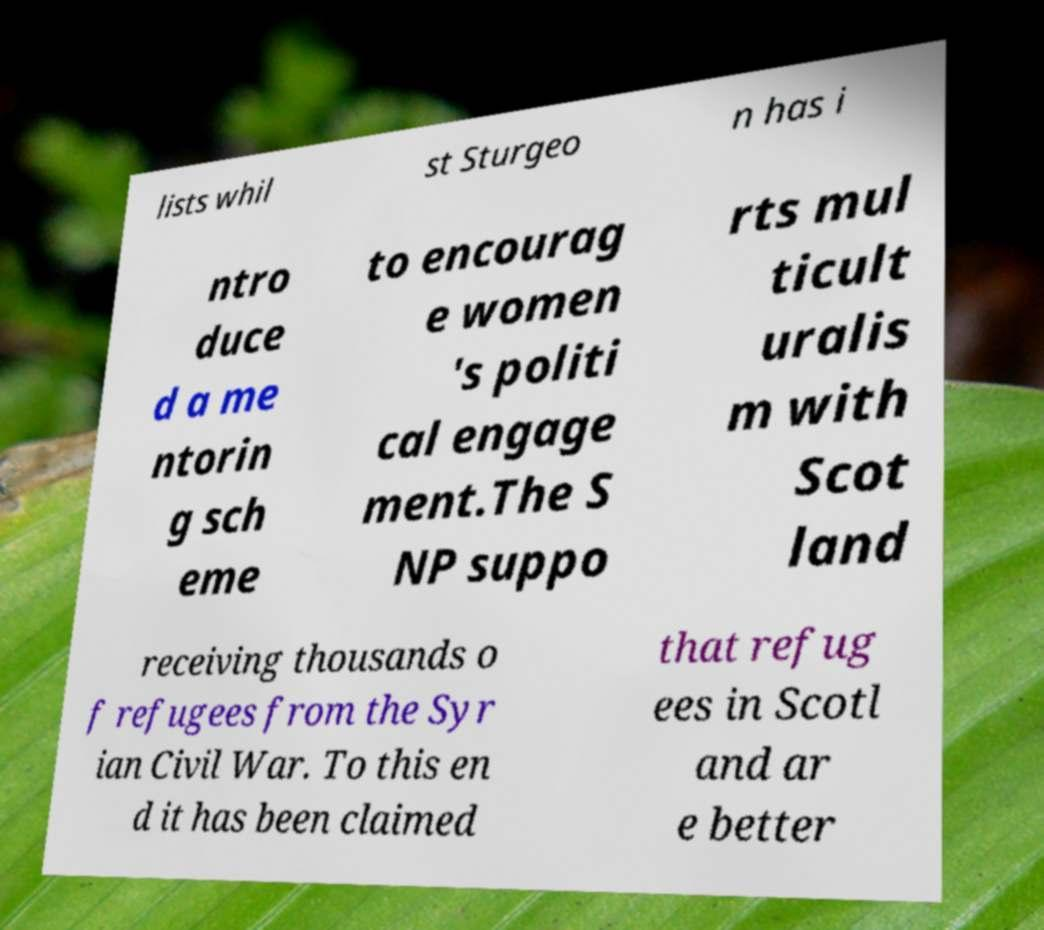Please read and relay the text visible in this image. What does it say? lists whil st Sturgeo n has i ntro duce d a me ntorin g sch eme to encourag e women 's politi cal engage ment.The S NP suppo rts mul ticult uralis m with Scot land receiving thousands o f refugees from the Syr ian Civil War. To this en d it has been claimed that refug ees in Scotl and ar e better 